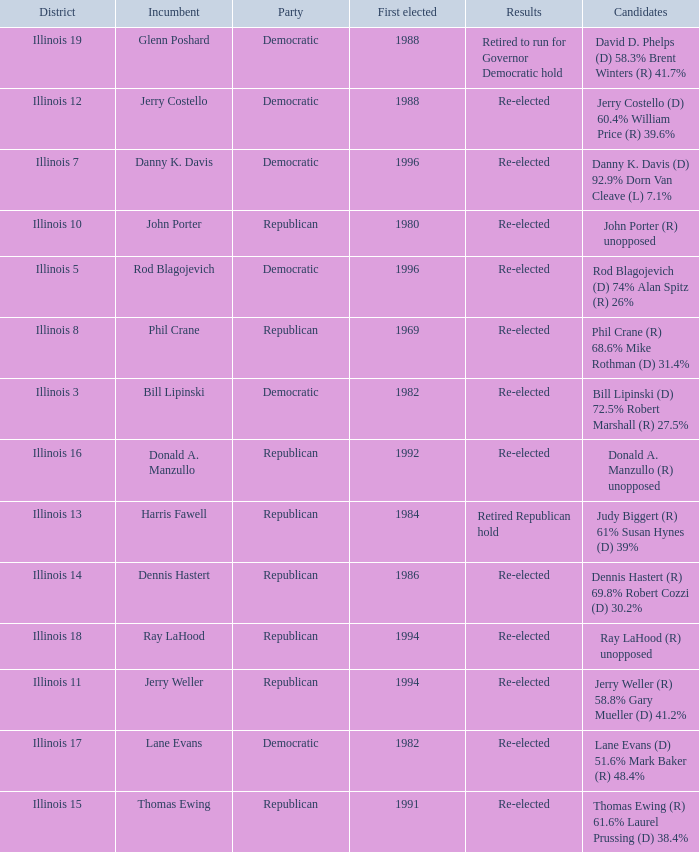Who were the candidates in the district where Jerry Costello won? Jerry Costello (D) 60.4% William Price (R) 39.6%. 